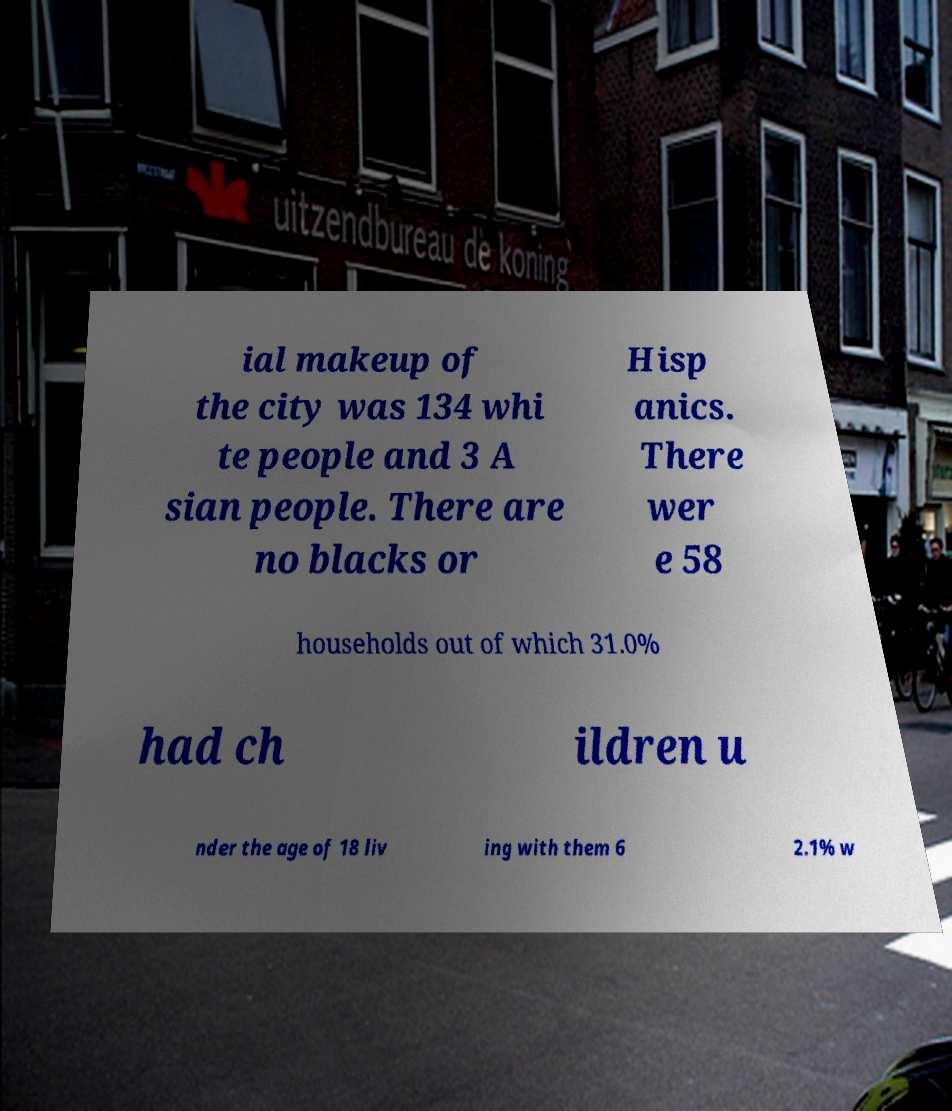For documentation purposes, I need the text within this image transcribed. Could you provide that? ial makeup of the city was 134 whi te people and 3 A sian people. There are no blacks or Hisp anics. There wer e 58 households out of which 31.0% had ch ildren u nder the age of 18 liv ing with them 6 2.1% w 